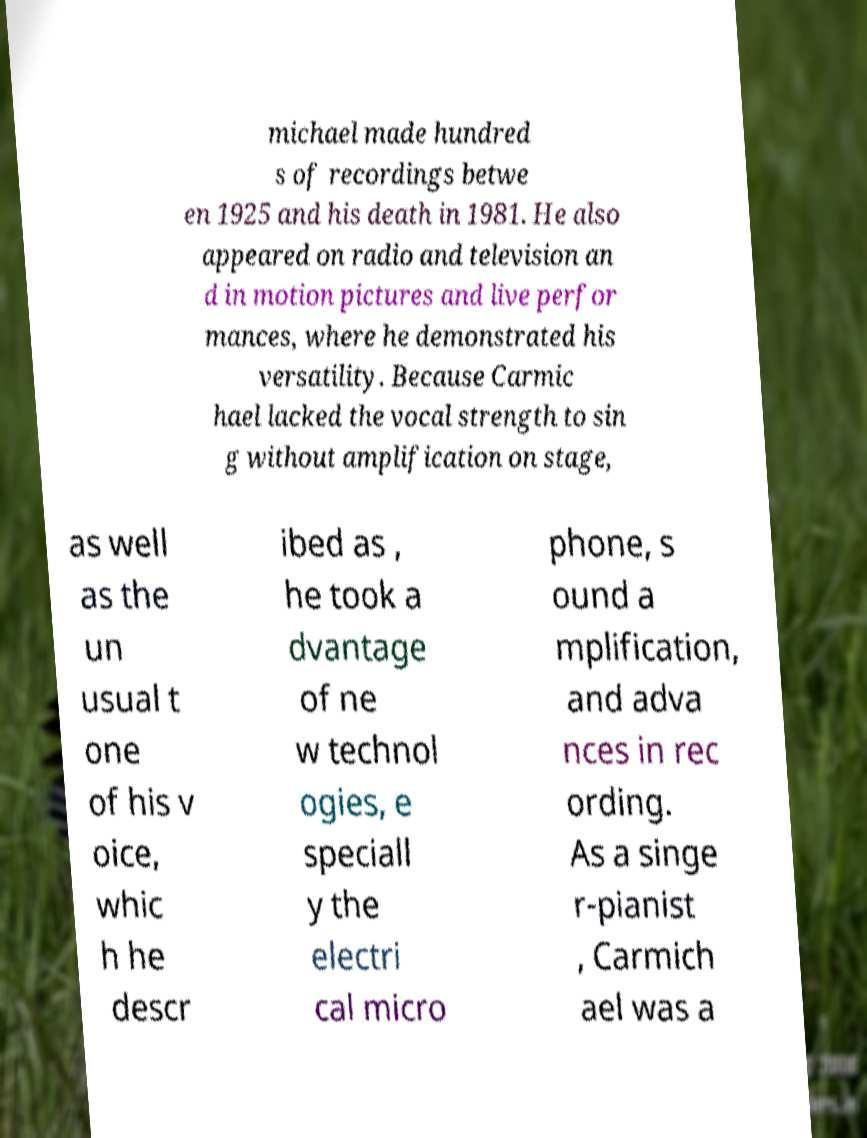Could you extract and type out the text from this image? michael made hundred s of recordings betwe en 1925 and his death in 1981. He also appeared on radio and television an d in motion pictures and live perfor mances, where he demonstrated his versatility. Because Carmic hael lacked the vocal strength to sin g without amplification on stage, as well as the un usual t one of his v oice, whic h he descr ibed as , he took a dvantage of ne w technol ogies, e speciall y the electri cal micro phone, s ound a mplification, and adva nces in rec ording. As a singe r-pianist , Carmich ael was a 